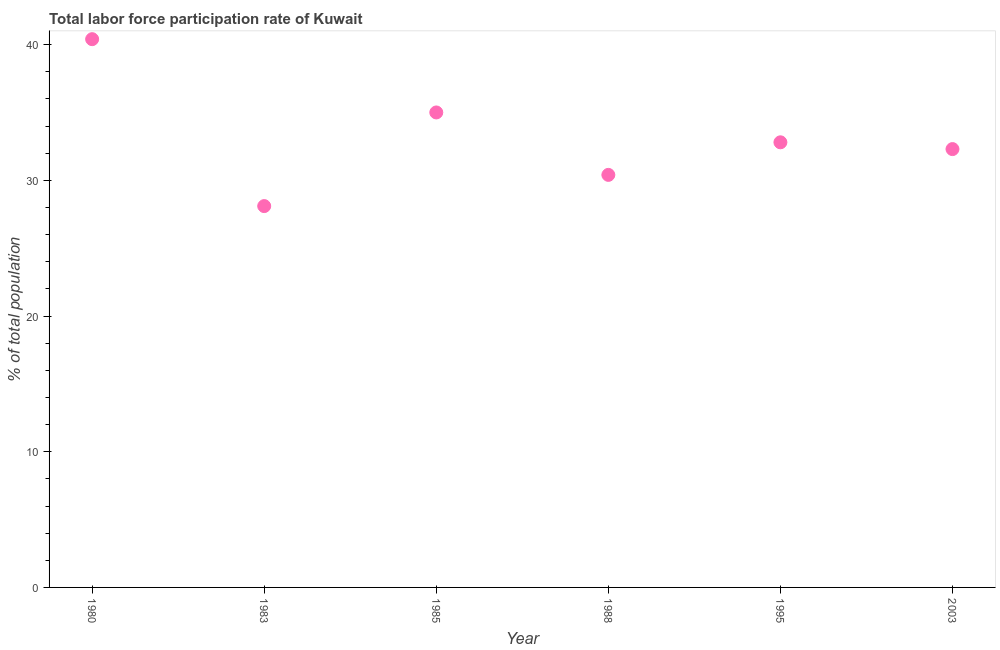What is the total labor force participation rate in 1983?
Your response must be concise. 28.1. Across all years, what is the maximum total labor force participation rate?
Offer a very short reply. 40.4. Across all years, what is the minimum total labor force participation rate?
Provide a succinct answer. 28.1. In which year was the total labor force participation rate maximum?
Offer a terse response. 1980. In which year was the total labor force participation rate minimum?
Provide a short and direct response. 1983. What is the sum of the total labor force participation rate?
Your answer should be compact. 199. What is the difference between the total labor force participation rate in 1983 and 1995?
Your response must be concise. -4.7. What is the average total labor force participation rate per year?
Your answer should be compact. 33.17. What is the median total labor force participation rate?
Give a very brief answer. 32.55. What is the ratio of the total labor force participation rate in 1988 to that in 1995?
Give a very brief answer. 0.93. Is the total labor force participation rate in 1985 less than that in 1995?
Your response must be concise. No. What is the difference between the highest and the second highest total labor force participation rate?
Keep it short and to the point. 5.4. Is the sum of the total labor force participation rate in 1983 and 1988 greater than the maximum total labor force participation rate across all years?
Make the answer very short. Yes. What is the difference between the highest and the lowest total labor force participation rate?
Make the answer very short. 12.3. Does the total labor force participation rate monotonically increase over the years?
Offer a terse response. No. How many years are there in the graph?
Give a very brief answer. 6. Does the graph contain any zero values?
Give a very brief answer. No. What is the title of the graph?
Your response must be concise. Total labor force participation rate of Kuwait. What is the label or title of the X-axis?
Your answer should be compact. Year. What is the label or title of the Y-axis?
Provide a succinct answer. % of total population. What is the % of total population in 1980?
Make the answer very short. 40.4. What is the % of total population in 1983?
Your answer should be compact. 28.1. What is the % of total population in 1985?
Provide a succinct answer. 35. What is the % of total population in 1988?
Offer a very short reply. 30.4. What is the % of total population in 1995?
Your answer should be very brief. 32.8. What is the % of total population in 2003?
Your answer should be very brief. 32.3. What is the difference between the % of total population in 1980 and 1983?
Keep it short and to the point. 12.3. What is the difference between the % of total population in 1980 and 1988?
Your response must be concise. 10. What is the difference between the % of total population in 1980 and 1995?
Your answer should be very brief. 7.6. What is the difference between the % of total population in 1983 and 1985?
Offer a terse response. -6.9. What is the difference between the % of total population in 1983 and 1988?
Keep it short and to the point. -2.3. What is the difference between the % of total population in 1983 and 1995?
Your answer should be compact. -4.7. What is the difference between the % of total population in 1983 and 2003?
Give a very brief answer. -4.2. What is the difference between the % of total population in 1985 and 1988?
Offer a very short reply. 4.6. What is the difference between the % of total population in 1985 and 1995?
Provide a short and direct response. 2.2. What is the difference between the % of total population in 1985 and 2003?
Provide a succinct answer. 2.7. What is the difference between the % of total population in 1988 and 1995?
Give a very brief answer. -2.4. What is the ratio of the % of total population in 1980 to that in 1983?
Your answer should be very brief. 1.44. What is the ratio of the % of total population in 1980 to that in 1985?
Offer a terse response. 1.15. What is the ratio of the % of total population in 1980 to that in 1988?
Offer a terse response. 1.33. What is the ratio of the % of total population in 1980 to that in 1995?
Your answer should be very brief. 1.23. What is the ratio of the % of total population in 1980 to that in 2003?
Your response must be concise. 1.25. What is the ratio of the % of total population in 1983 to that in 1985?
Offer a very short reply. 0.8. What is the ratio of the % of total population in 1983 to that in 1988?
Provide a succinct answer. 0.92. What is the ratio of the % of total population in 1983 to that in 1995?
Your answer should be compact. 0.86. What is the ratio of the % of total population in 1983 to that in 2003?
Provide a short and direct response. 0.87. What is the ratio of the % of total population in 1985 to that in 1988?
Ensure brevity in your answer.  1.15. What is the ratio of the % of total population in 1985 to that in 1995?
Provide a succinct answer. 1.07. What is the ratio of the % of total population in 1985 to that in 2003?
Ensure brevity in your answer.  1.08. What is the ratio of the % of total population in 1988 to that in 1995?
Ensure brevity in your answer.  0.93. What is the ratio of the % of total population in 1988 to that in 2003?
Keep it short and to the point. 0.94. 